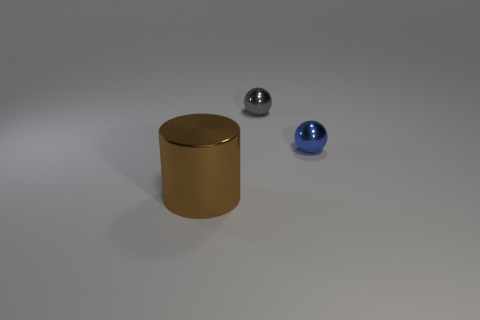What size is the gray sphere that is made of the same material as the blue sphere?
Offer a very short reply. Small. Is there any other thing that has the same color as the big object?
Your response must be concise. No. There is a tiny metal thing that is behind the small blue thing; what is its color?
Keep it short and to the point. Gray. Is there a brown shiny thing behind the small metal thing that is behind the tiny shiny ball on the right side of the tiny gray ball?
Your answer should be very brief. No. Are there more metal balls left of the tiny blue thing than things?
Provide a succinct answer. No. Do the tiny metal object right of the gray shiny sphere and the big object have the same shape?
Provide a short and direct response. No. Are there any other things that are the same material as the cylinder?
Provide a short and direct response. Yes. How many objects are either metal cylinders or metallic things that are on the left side of the gray object?
Offer a terse response. 1. There is a object that is both behind the metallic cylinder and in front of the gray sphere; what is its size?
Your answer should be very brief. Small. Are there more small balls to the left of the gray object than big brown metallic things that are on the right side of the brown shiny object?
Provide a short and direct response. No. 